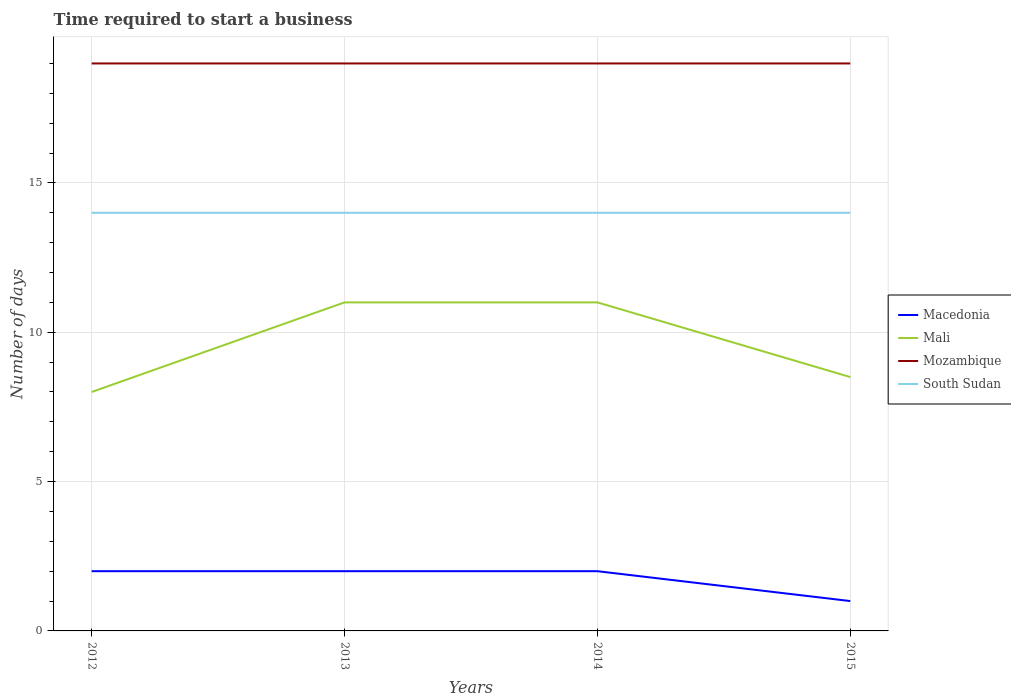How many different coloured lines are there?
Ensure brevity in your answer.  4. Is the number of lines equal to the number of legend labels?
Your answer should be compact. Yes. Across all years, what is the maximum number of days required to start a business in Mozambique?
Provide a succinct answer. 19. What is the difference between the highest and the second highest number of days required to start a business in Macedonia?
Offer a terse response. 1. How many lines are there?
Provide a short and direct response. 4. How many years are there in the graph?
Provide a succinct answer. 4. What is the difference between two consecutive major ticks on the Y-axis?
Ensure brevity in your answer.  5. Does the graph contain any zero values?
Your answer should be very brief. No. Where does the legend appear in the graph?
Give a very brief answer. Center right. How many legend labels are there?
Ensure brevity in your answer.  4. What is the title of the graph?
Keep it short and to the point. Time required to start a business. What is the label or title of the Y-axis?
Offer a terse response. Number of days. What is the Number of days in Mali in 2012?
Make the answer very short. 8. What is the Number of days in Mozambique in 2012?
Offer a terse response. 19. What is the Number of days of South Sudan in 2012?
Provide a succinct answer. 14. What is the Number of days of Macedonia in 2013?
Keep it short and to the point. 2. What is the Number of days of Mali in 2013?
Offer a very short reply. 11. What is the Number of days of Mozambique in 2013?
Your answer should be very brief. 19. What is the Number of days of South Sudan in 2013?
Make the answer very short. 14. What is the Number of days in Macedonia in 2014?
Provide a succinct answer. 2. What is the Number of days in Mali in 2015?
Your answer should be very brief. 8.5. What is the Number of days of South Sudan in 2015?
Offer a very short reply. 14. Across all years, what is the maximum Number of days of Mali?
Make the answer very short. 11. Across all years, what is the maximum Number of days of Mozambique?
Give a very brief answer. 19. Across all years, what is the minimum Number of days in Mozambique?
Your answer should be very brief. 19. Across all years, what is the minimum Number of days in South Sudan?
Your answer should be very brief. 14. What is the total Number of days in Mali in the graph?
Offer a very short reply. 38.5. What is the total Number of days in Mozambique in the graph?
Make the answer very short. 76. What is the difference between the Number of days in Macedonia in 2012 and that in 2013?
Your response must be concise. 0. What is the difference between the Number of days of Mali in 2012 and that in 2013?
Ensure brevity in your answer.  -3. What is the difference between the Number of days of South Sudan in 2012 and that in 2013?
Ensure brevity in your answer.  0. What is the difference between the Number of days in Macedonia in 2012 and that in 2014?
Offer a very short reply. 0. What is the difference between the Number of days of Mali in 2012 and that in 2014?
Your answer should be compact. -3. What is the difference between the Number of days in Mali in 2012 and that in 2015?
Your answer should be compact. -0.5. What is the difference between the Number of days of Mozambique in 2012 and that in 2015?
Your answer should be compact. 0. What is the difference between the Number of days of South Sudan in 2012 and that in 2015?
Keep it short and to the point. 0. What is the difference between the Number of days in Mozambique in 2013 and that in 2014?
Your response must be concise. 0. What is the difference between the Number of days in Macedonia in 2013 and that in 2015?
Ensure brevity in your answer.  1. What is the difference between the Number of days of Mozambique in 2013 and that in 2015?
Your answer should be compact. 0. What is the difference between the Number of days of South Sudan in 2013 and that in 2015?
Keep it short and to the point. 0. What is the difference between the Number of days in Mozambique in 2014 and that in 2015?
Your response must be concise. 0. What is the difference between the Number of days of South Sudan in 2014 and that in 2015?
Ensure brevity in your answer.  0. What is the difference between the Number of days in Macedonia in 2012 and the Number of days in Mali in 2013?
Ensure brevity in your answer.  -9. What is the difference between the Number of days in Mali in 2012 and the Number of days in Mozambique in 2013?
Your answer should be very brief. -11. What is the difference between the Number of days of Mali in 2012 and the Number of days of South Sudan in 2013?
Make the answer very short. -6. What is the difference between the Number of days in Mali in 2012 and the Number of days in Mozambique in 2014?
Provide a short and direct response. -11. What is the difference between the Number of days of Mozambique in 2012 and the Number of days of South Sudan in 2014?
Your answer should be very brief. 5. What is the difference between the Number of days in Macedonia in 2012 and the Number of days in Mozambique in 2015?
Your answer should be very brief. -17. What is the difference between the Number of days in Macedonia in 2012 and the Number of days in South Sudan in 2015?
Offer a terse response. -12. What is the difference between the Number of days in Mali in 2012 and the Number of days in Mozambique in 2015?
Provide a short and direct response. -11. What is the difference between the Number of days of Mali in 2012 and the Number of days of South Sudan in 2015?
Your answer should be very brief. -6. What is the difference between the Number of days in Mozambique in 2012 and the Number of days in South Sudan in 2015?
Provide a short and direct response. 5. What is the difference between the Number of days in Macedonia in 2013 and the Number of days in Mali in 2014?
Your answer should be compact. -9. What is the difference between the Number of days of Macedonia in 2013 and the Number of days of South Sudan in 2014?
Keep it short and to the point. -12. What is the difference between the Number of days of Macedonia in 2013 and the Number of days of Mali in 2015?
Your answer should be compact. -6.5. What is the difference between the Number of days of Macedonia in 2013 and the Number of days of Mozambique in 2015?
Your response must be concise. -17. What is the difference between the Number of days of Mali in 2013 and the Number of days of Mozambique in 2015?
Provide a short and direct response. -8. What is the difference between the Number of days of Mozambique in 2013 and the Number of days of South Sudan in 2015?
Your answer should be compact. 5. What is the difference between the Number of days of Macedonia in 2014 and the Number of days of Mali in 2015?
Your answer should be very brief. -6.5. What is the difference between the Number of days in Macedonia in 2014 and the Number of days in Mozambique in 2015?
Offer a terse response. -17. What is the difference between the Number of days in Mali in 2014 and the Number of days in South Sudan in 2015?
Give a very brief answer. -3. What is the average Number of days of Macedonia per year?
Make the answer very short. 1.75. What is the average Number of days of Mali per year?
Ensure brevity in your answer.  9.62. What is the average Number of days of Mozambique per year?
Give a very brief answer. 19. What is the average Number of days in South Sudan per year?
Keep it short and to the point. 14. In the year 2012, what is the difference between the Number of days of Macedonia and Number of days of South Sudan?
Ensure brevity in your answer.  -12. In the year 2012, what is the difference between the Number of days in Mali and Number of days in Mozambique?
Offer a very short reply. -11. In the year 2012, what is the difference between the Number of days in Mali and Number of days in South Sudan?
Your response must be concise. -6. In the year 2012, what is the difference between the Number of days of Mozambique and Number of days of South Sudan?
Your response must be concise. 5. In the year 2013, what is the difference between the Number of days in Macedonia and Number of days in Mali?
Your answer should be compact. -9. In the year 2013, what is the difference between the Number of days of Macedonia and Number of days of Mozambique?
Offer a very short reply. -17. In the year 2013, what is the difference between the Number of days of Mali and Number of days of Mozambique?
Give a very brief answer. -8. In the year 2013, what is the difference between the Number of days in Mali and Number of days in South Sudan?
Make the answer very short. -3. In the year 2013, what is the difference between the Number of days of Mozambique and Number of days of South Sudan?
Give a very brief answer. 5. In the year 2014, what is the difference between the Number of days of Macedonia and Number of days of Mali?
Make the answer very short. -9. In the year 2014, what is the difference between the Number of days of Macedonia and Number of days of Mozambique?
Make the answer very short. -17. In the year 2014, what is the difference between the Number of days of Mali and Number of days of Mozambique?
Provide a short and direct response. -8. In the year 2014, what is the difference between the Number of days in Mali and Number of days in South Sudan?
Your response must be concise. -3. In the year 2015, what is the difference between the Number of days of Mali and Number of days of Mozambique?
Offer a terse response. -10.5. What is the ratio of the Number of days in Macedonia in 2012 to that in 2013?
Ensure brevity in your answer.  1. What is the ratio of the Number of days of Mali in 2012 to that in 2013?
Keep it short and to the point. 0.73. What is the ratio of the Number of days of Mozambique in 2012 to that in 2013?
Provide a succinct answer. 1. What is the ratio of the Number of days in Mali in 2012 to that in 2014?
Offer a terse response. 0.73. What is the ratio of the Number of days in South Sudan in 2012 to that in 2014?
Your answer should be very brief. 1. What is the ratio of the Number of days in Mali in 2012 to that in 2015?
Ensure brevity in your answer.  0.94. What is the ratio of the Number of days in Mozambique in 2012 to that in 2015?
Provide a succinct answer. 1. What is the ratio of the Number of days of Macedonia in 2013 to that in 2014?
Offer a very short reply. 1. What is the ratio of the Number of days of Mozambique in 2013 to that in 2014?
Give a very brief answer. 1. What is the ratio of the Number of days of Mali in 2013 to that in 2015?
Offer a very short reply. 1.29. What is the ratio of the Number of days of South Sudan in 2013 to that in 2015?
Give a very brief answer. 1. What is the ratio of the Number of days of Macedonia in 2014 to that in 2015?
Provide a succinct answer. 2. What is the ratio of the Number of days in Mali in 2014 to that in 2015?
Offer a very short reply. 1.29. What is the difference between the highest and the second highest Number of days of Macedonia?
Make the answer very short. 0. What is the difference between the highest and the second highest Number of days of South Sudan?
Your answer should be compact. 0. What is the difference between the highest and the lowest Number of days in Macedonia?
Your answer should be very brief. 1. What is the difference between the highest and the lowest Number of days in Mali?
Ensure brevity in your answer.  3. What is the difference between the highest and the lowest Number of days of Mozambique?
Offer a terse response. 0. 